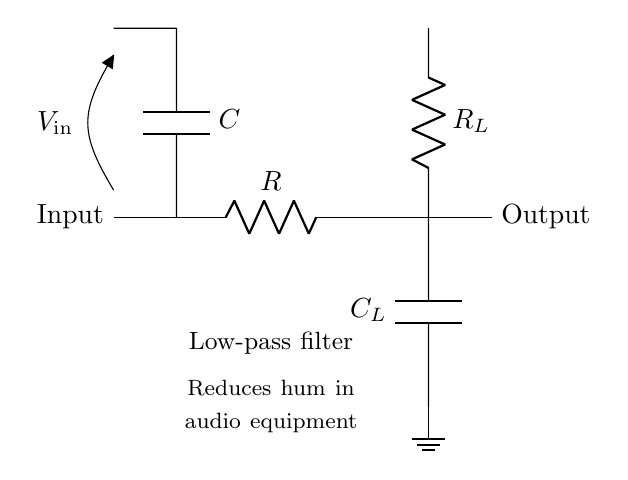What type of filter is shown in the circuit? The circuit is a low-pass filter, as indicated by the labeling within the diagram. A low-pass filter allows signals with a frequency lower than a certain cutoff frequency to pass through while attenuating higher frequencies.
Answer: low-pass filter What components are used in this low-pass filter? The circuit diagram shows a resistor and a capacitor, specifically labeled as R for the resistor and C for the capacitor. These components work together to create the low-pass filter effect.
Answer: resistor and capacitor What is the role of the capacitor labeled C in the circuit? The capacitor in a low-pass filter helps to store and release energy, allowing low frequencies to pass through while filtering out high frequencies. This filtering effect is essential for reducing hum in audio equipment.
Answer: filter high frequencies What is connected to the output of the circuit? The output of the circuit connects to a capacitor labeled C sub L and a resistor labeled R sub L. These components help further stabilize the output signal, maintaining the intended filtering of the audio signals.
Answer: capacitor and resistor What does the label V sub in represent in this circuit? The label V sub in refers to the input voltage of the circuit. It represents the voltage signal that is fed into the circuit for filtering, which will be modified based on the properties of the low-pass filter.
Answer: input voltage What is the purpose of the labeled ground in the circuit? The ground in a circuit serves as a reference point for voltage levels and ensures a common return path for current. It helps maintain safe operation and stability in the overall circuit.
Answer: reference point for voltage What is the expected output of the low-pass filter circuit? The expected output will be a cleaner audio signal with reduced hum, as the low-pass filter allows lower frequency components to pass while attenuating higher frequency noise.
Answer: cleaner audio signal 